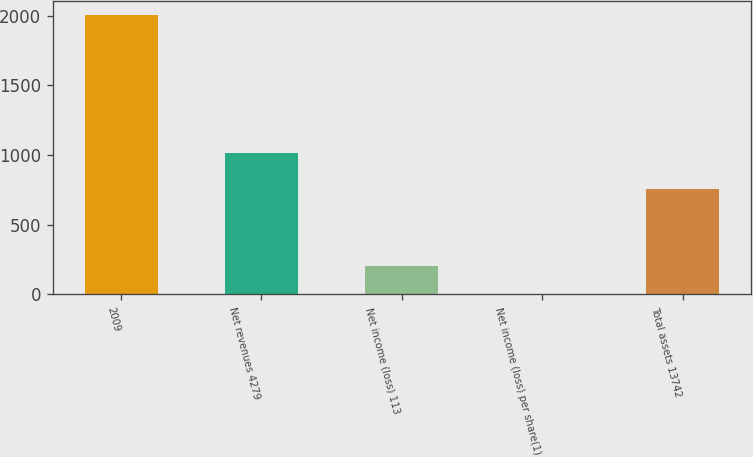Convert chart to OTSL. <chart><loc_0><loc_0><loc_500><loc_500><bar_chart><fcel>2009<fcel>Net revenues 4279<fcel>Net income (loss) 113<fcel>Net income (loss) per share(1)<fcel>Total assets 13742<nl><fcel>2006<fcel>1018<fcel>200.82<fcel>0.24<fcel>758<nl></chart> 